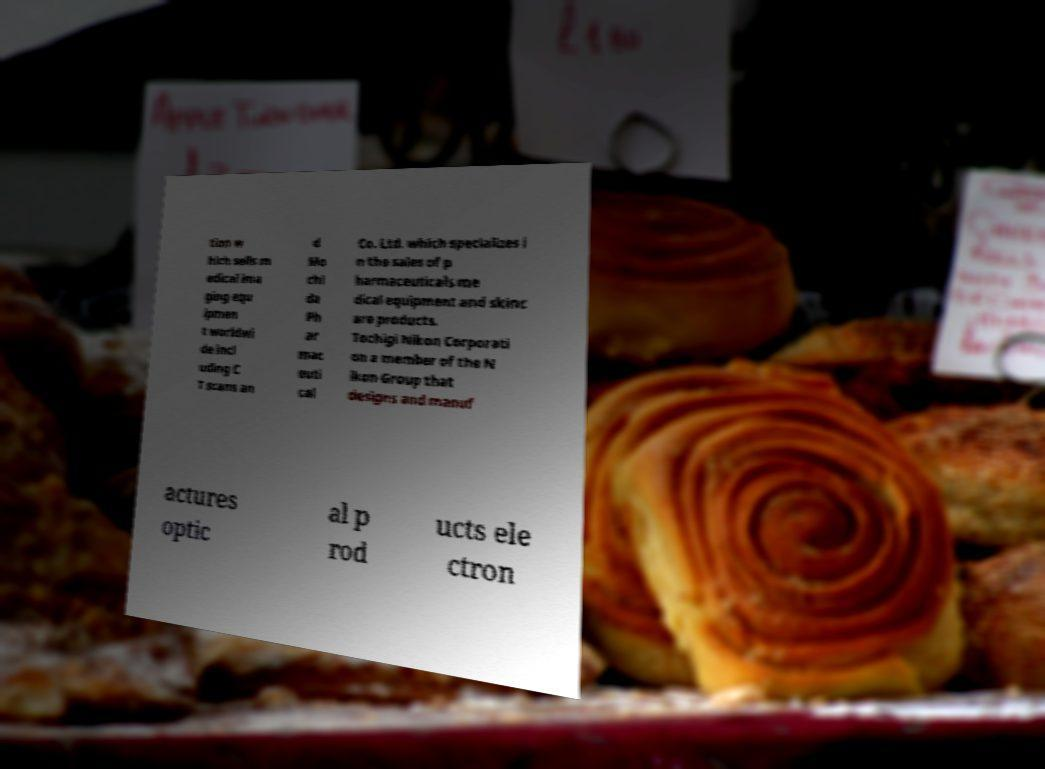Please identify and transcribe the text found in this image. tion w hich sells m edical ima ging equ ipmen t worldwi de incl uding C T scans an d Mo chi da Ph ar mac euti cal Co. Ltd. which specializes i n the sales of p harmaceuticals me dical equipment and skinc are products. Tochigi Nikon Corporati on a member of the N ikon Group that designs and manuf actures optic al p rod ucts ele ctron 